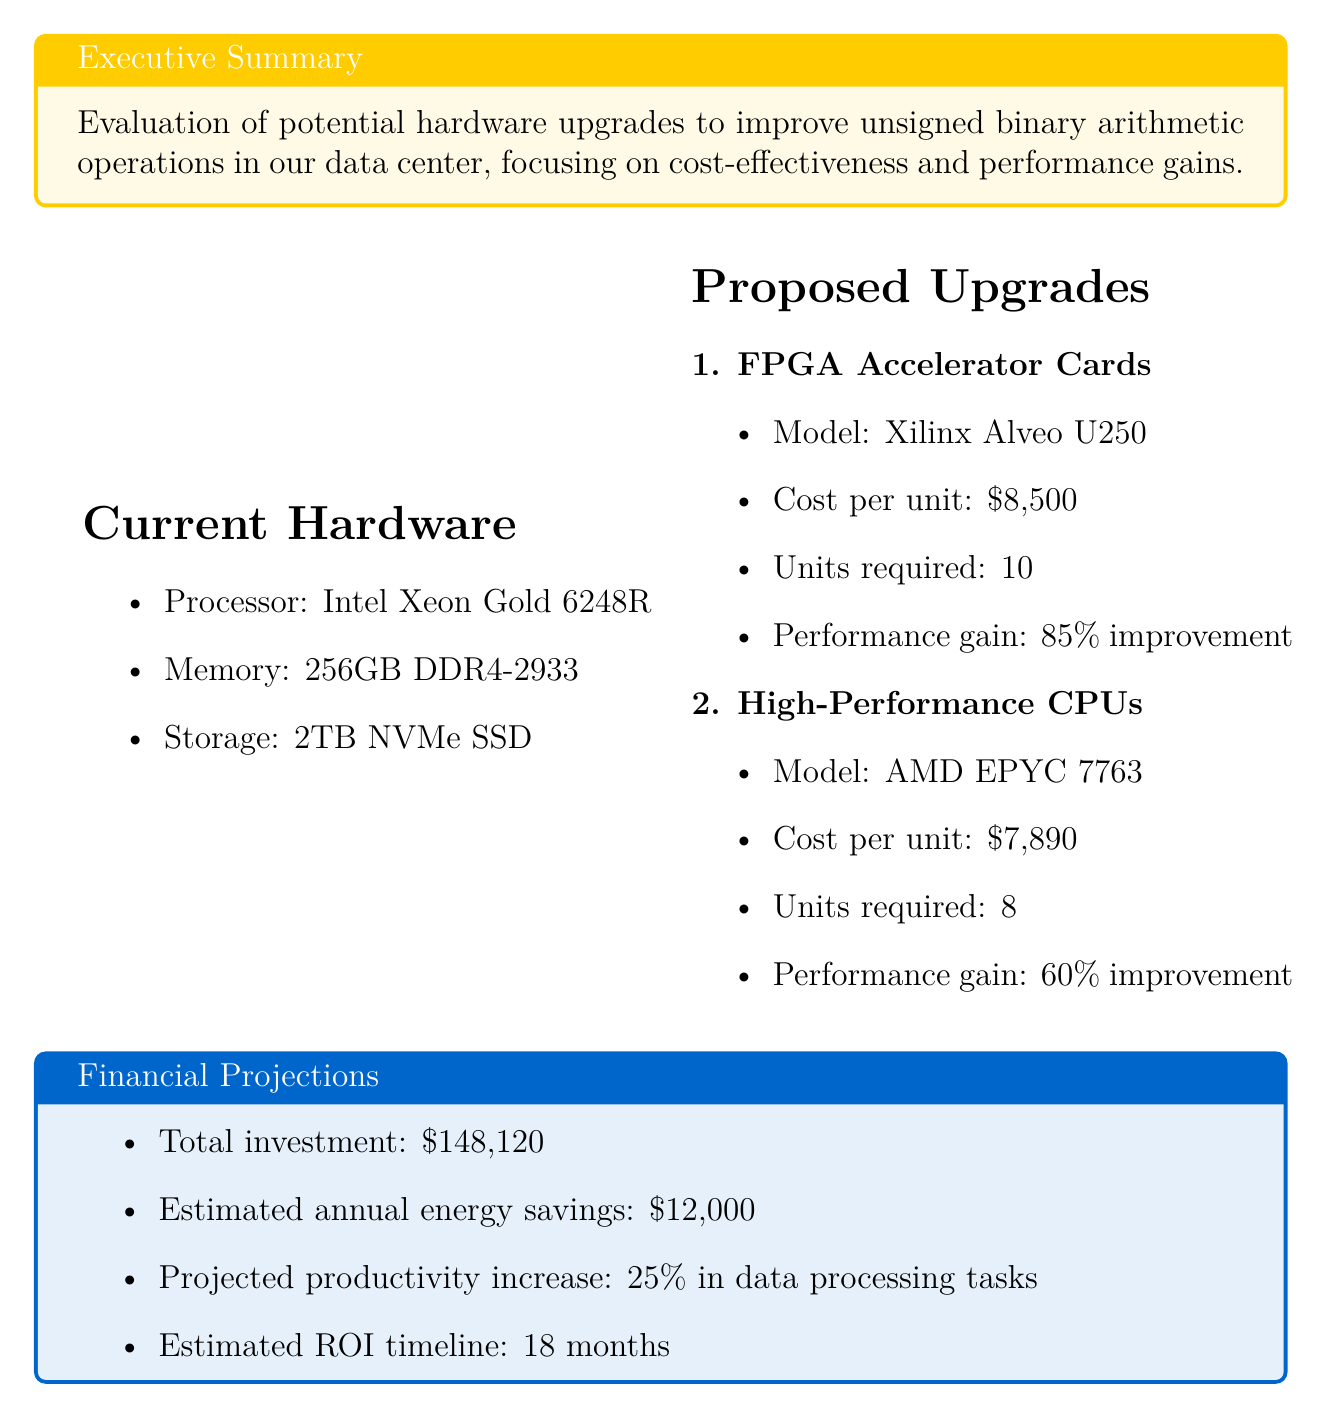What is the cost per unit for FPGA Accelerator Cards? The cost per unit is explicitly stated in the proposed upgrades section for FPGA Accelerator Cards, which is $8,500.
Answer: $8,500 How many units of High-Performance CPUs are required? The required units for High-Performance CPUs are mentioned in the proposed upgrades section, which specifies 8 units.
Answer: 8 What is the expected performance gain for FPGA Accelerator Cards? The expected performance gain for FPGA Accelerator Cards is detailed in the proposed upgrades, which indicates an 85% improvement in unsigned binary arithmetic operations.
Answer: 85% What is the total investment amount? The total investment amount is provided in the financial projections section, which states $148,120.
Answer: $148,120 What is the estimated ROI timeline? The estimated ROI timeline is highlighted in the financial projections, which states it will take 18 months.
Answer: 18 months What is the estimated annual energy savings? The estimated annual energy savings is indicated in the financial projections, specifying $12,000.
Answer: $12,000 What is the projected productivity increase in data processing tasks? The projected productivity increase is detailed in the financial projections section, indicating a 25% increase.
Answer: 25% What is the implementation time for the proposed upgrades? The implementation time is outlined under risk assessment, which states 2 weeks of planned downtime.
Answer: 2 weeks Is staff training required for the implementation? The requirement for staff training is noted in the risk assessment section, which specifies 2 days of specialized training for the engineering team.
Answer: 2 days 